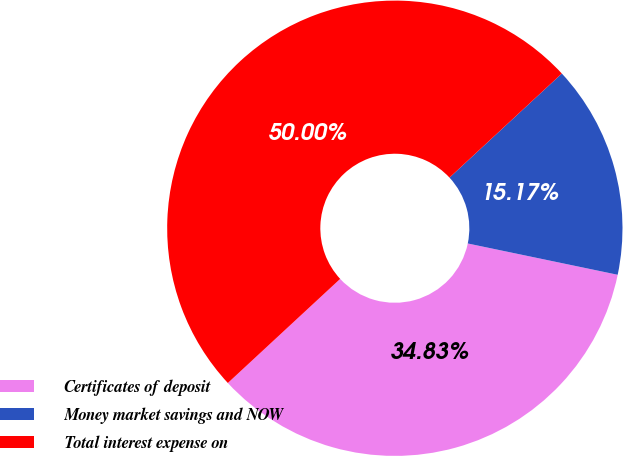Convert chart. <chart><loc_0><loc_0><loc_500><loc_500><pie_chart><fcel>Certificates of deposit<fcel>Money market savings and NOW<fcel>Total interest expense on<nl><fcel>34.83%<fcel>15.17%<fcel>50.0%<nl></chart> 